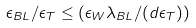Convert formula to latex. <formula><loc_0><loc_0><loc_500><loc_500>\epsilon _ { B L } / \epsilon _ { T } \leq \left ( \epsilon _ { W } \lambda _ { B L } / ( d \epsilon _ { T } ) \right )</formula> 